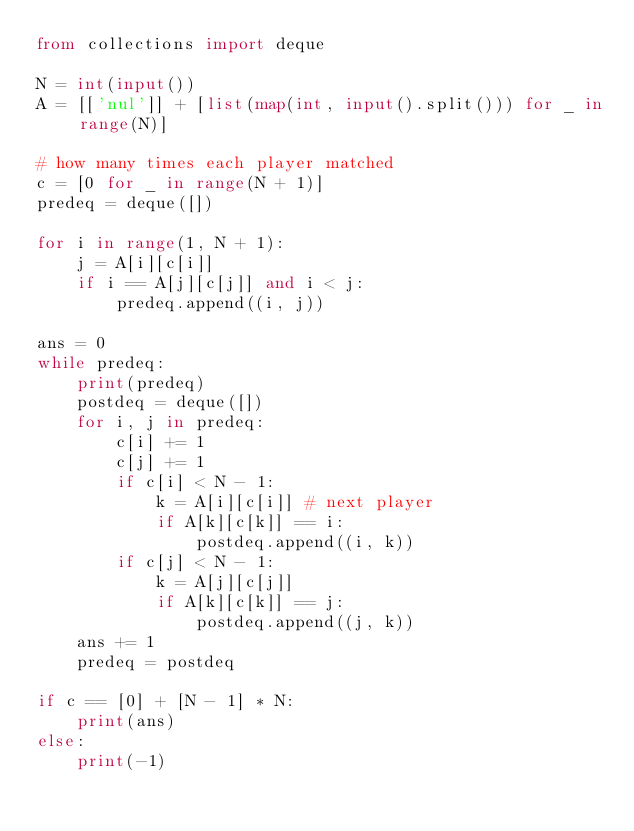Convert code to text. <code><loc_0><loc_0><loc_500><loc_500><_Python_>from collections import deque

N = int(input())
A = [['nul']] + [list(map(int, input().split())) for _ in range(N)]

# how many times each player matched
c = [0 for _ in range(N + 1)]
predeq = deque([])

for i in range(1, N + 1):
    j = A[i][c[i]]
    if i == A[j][c[j]] and i < j:
        predeq.append((i, j))

ans = 0
while predeq:
    print(predeq)
    postdeq = deque([])
    for i, j in predeq:
        c[i] += 1
        c[j] += 1
        if c[i] < N - 1:
            k = A[i][c[i]] # next player
            if A[k][c[k]] == i:
                postdeq.append((i, k))
        if c[j] < N - 1:
            k = A[j][c[j]]
            if A[k][c[k]] == j:
                postdeq.append((j, k))
    ans += 1
    predeq = postdeq

if c == [0] + [N - 1] * N:
    print(ans)
else:
    print(-1)
</code> 